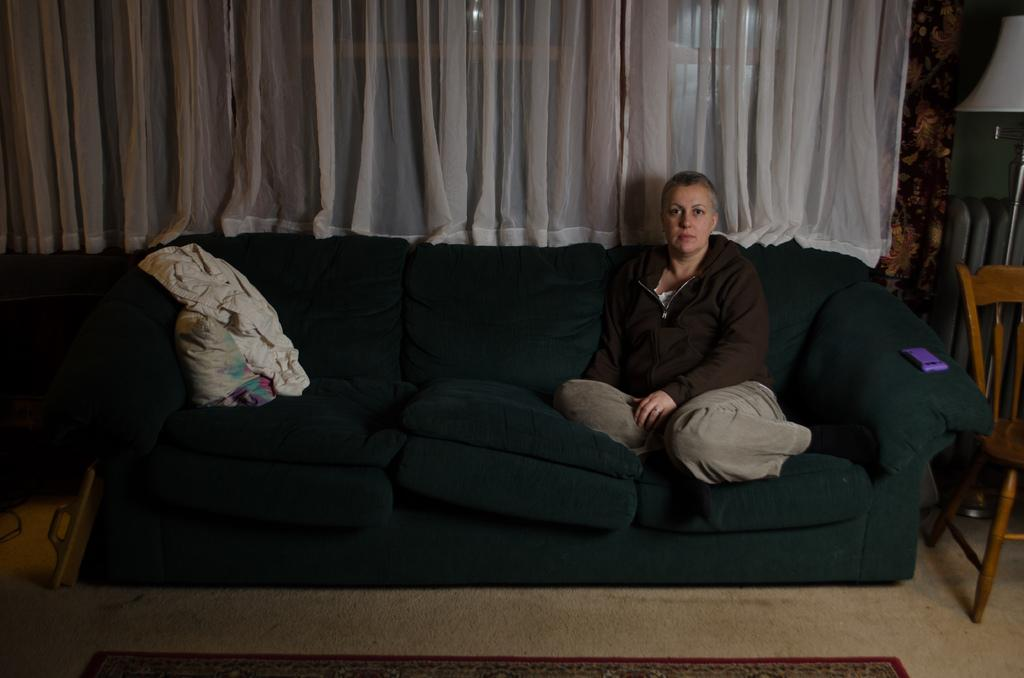Who or what is in the image? There is a person in the image. What is the person wearing? The person is wearing a brown jacket. What is the person sitting on? The person is sitting on a black sofa. What is beside the person? There is a chair beside the person. What is behind the person? There is a curtain behind the person. How many ants can be seen crawling on the person's lip in the image? There are no ants visible in the image, and the person's lip is not mentioned in the provided facts. 